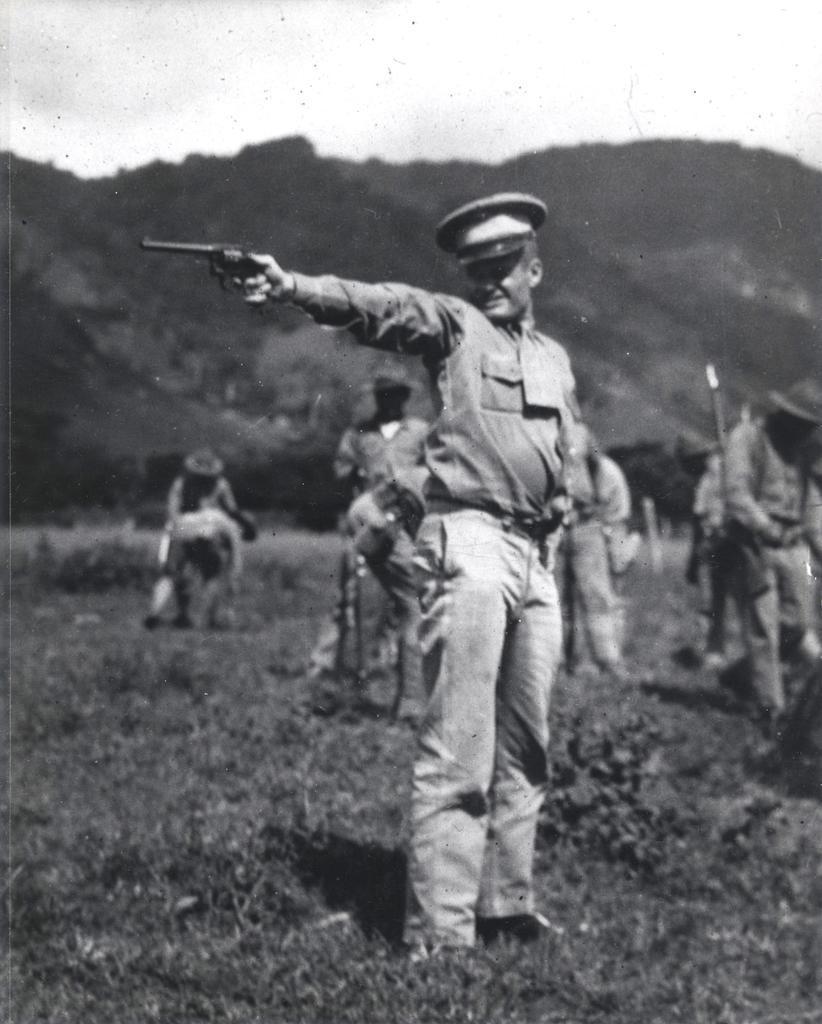In one or two sentences, can you explain what this image depicts? This is a black and white image. In this image, we can see a person holding a gun and standing on the grass. In the background, we can see people, plants, trees, hill and the sky. 